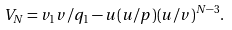<formula> <loc_0><loc_0><loc_500><loc_500>V _ { N } = v _ { 1 } v / q _ { 1 } - u ( u / p ) ( u / v ) ^ { N - 3 } .</formula> 